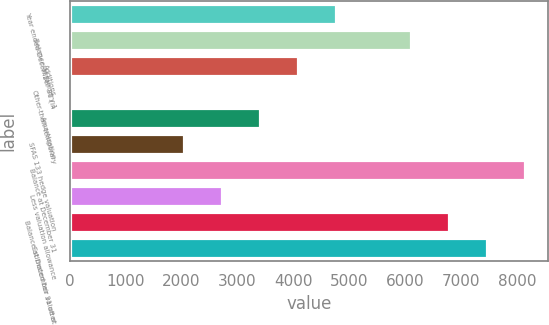Convert chart. <chart><loc_0><loc_0><loc_500><loc_500><bar_chart><fcel>Year ended December 31 (in<fcel>Balance at January 1<fcel>Additions<fcel>Other-than-temporary<fcel>Amortization<fcel>SFAS 133 hedge valuation<fcel>Balance at December 31<fcel>Less valuation allowance<fcel>Balance at December 31 after<fcel>Estimated fair value at<nl><fcel>4761.7<fcel>6111<fcel>4081.6<fcel>1<fcel>3401.5<fcel>2041.3<fcel>8151.3<fcel>2721.4<fcel>6791.1<fcel>7471.2<nl></chart> 